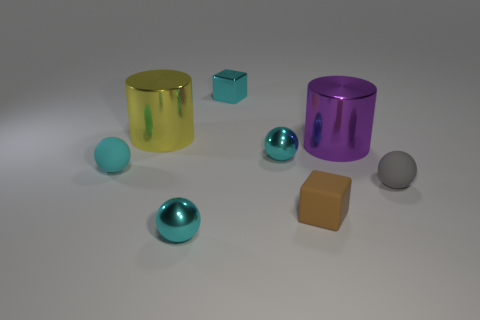Subtract all cyan blocks. How many cyan spheres are left? 3 Add 2 purple cylinders. How many objects exist? 10 Subtract all blocks. How many objects are left? 6 Add 8 small metallic spheres. How many small metallic spheres exist? 10 Subtract 0 cyan cylinders. How many objects are left? 8 Subtract all big blue shiny cubes. Subtract all tiny metallic things. How many objects are left? 5 Add 2 big things. How many big things are left? 4 